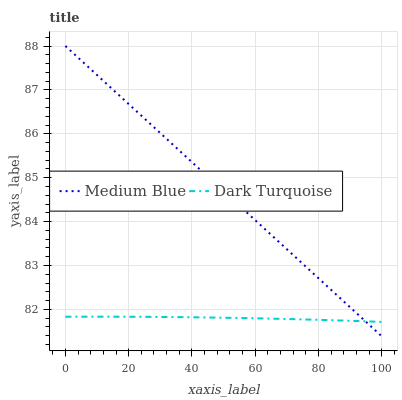Does Dark Turquoise have the minimum area under the curve?
Answer yes or no. Yes. Does Medium Blue have the maximum area under the curve?
Answer yes or no. Yes. Does Medium Blue have the minimum area under the curve?
Answer yes or no. No. Is Medium Blue the smoothest?
Answer yes or no. Yes. Is Dark Turquoise the roughest?
Answer yes or no. Yes. Is Medium Blue the roughest?
Answer yes or no. No. Does Medium Blue have the lowest value?
Answer yes or no. Yes. Does Medium Blue have the highest value?
Answer yes or no. Yes. Does Dark Turquoise intersect Medium Blue?
Answer yes or no. Yes. Is Dark Turquoise less than Medium Blue?
Answer yes or no. No. Is Dark Turquoise greater than Medium Blue?
Answer yes or no. No. 